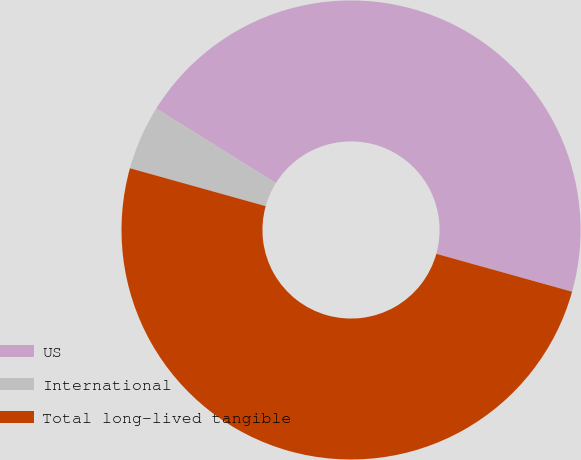<chart> <loc_0><loc_0><loc_500><loc_500><pie_chart><fcel>US<fcel>International<fcel>Total long-lived tangible<nl><fcel>45.46%<fcel>4.54%<fcel>50.0%<nl></chart> 